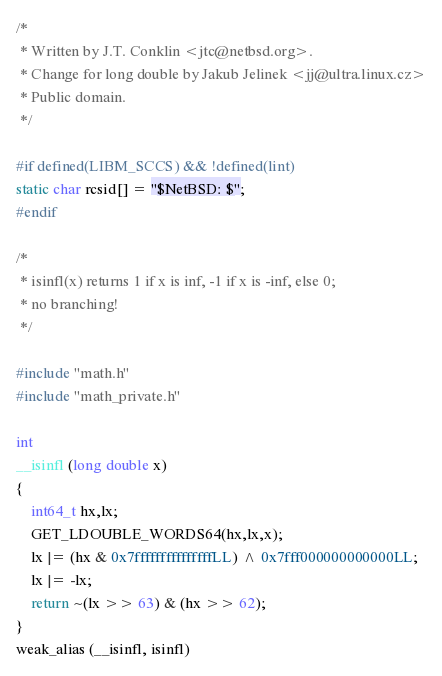<code> <loc_0><loc_0><loc_500><loc_500><_C_>/*
 * Written by J.T. Conklin <jtc@netbsd.org>.
 * Change for long double by Jakub Jelinek <jj@ultra.linux.cz>
 * Public domain.
 */

#if defined(LIBM_SCCS) && !defined(lint)
static char rcsid[] = "$NetBSD: $";
#endif

/*
 * isinfl(x) returns 1 if x is inf, -1 if x is -inf, else 0;
 * no branching!
 */

#include "math.h"
#include "math_private.h"

int
__isinfl (long double x)
{
	int64_t hx,lx;
	GET_LDOUBLE_WORDS64(hx,lx,x);
	lx |= (hx & 0x7fffffffffffffffLL) ^ 0x7fff000000000000LL;
	lx |= -lx;
	return ~(lx >> 63) & (hx >> 62);
}
weak_alias (__isinfl, isinfl)
</code> 